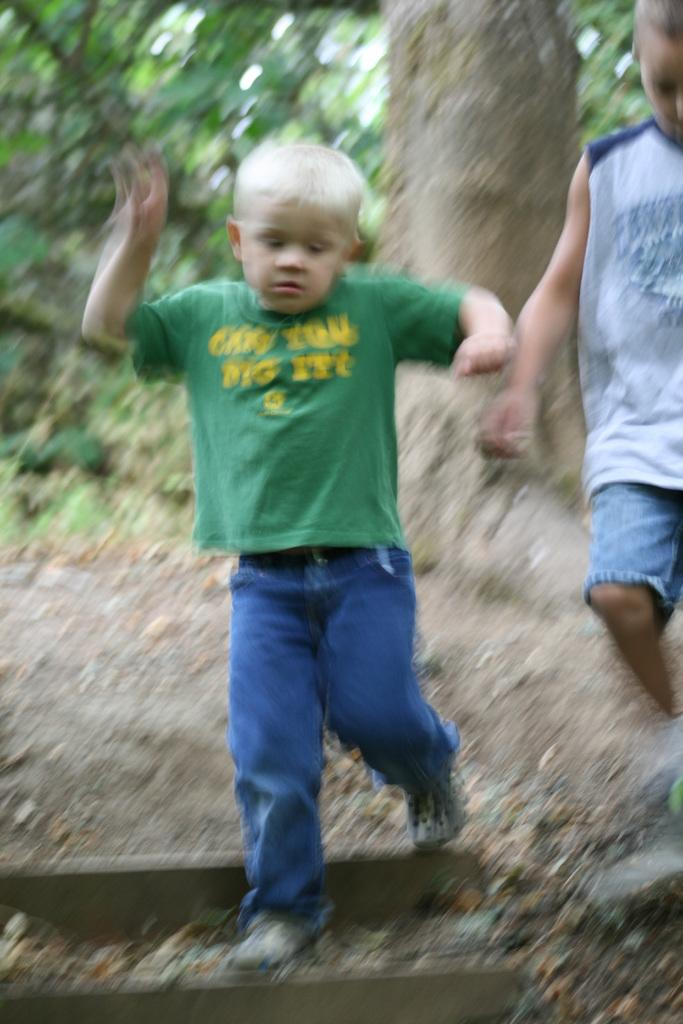How many people are in the image? There are two boys in the image. What are the boys doing in the image? The boys are walking on the ground. What can be seen in the background of the image? There are trees in the background of the image. How would you describe the background of the image? The background appears blurry. What type of pain is the carpenter experiencing in the image? There is no carpenter present in the image, and therefore no pain can be observed. 